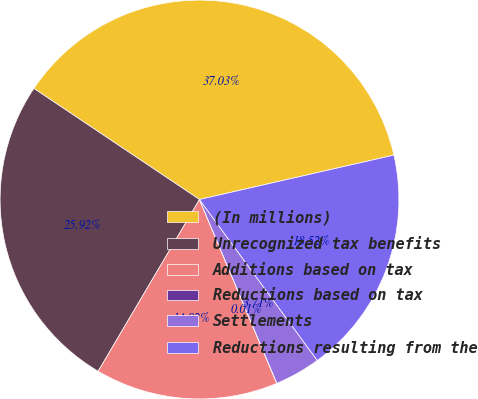<chart> <loc_0><loc_0><loc_500><loc_500><pie_chart><fcel>(In millions)<fcel>Unrecognized tax benefits<fcel>Additions based on tax<fcel>Reductions based on tax<fcel>Settlements<fcel>Reductions resulting from the<nl><fcel>37.03%<fcel>25.92%<fcel>14.82%<fcel>0.01%<fcel>3.71%<fcel>18.52%<nl></chart> 